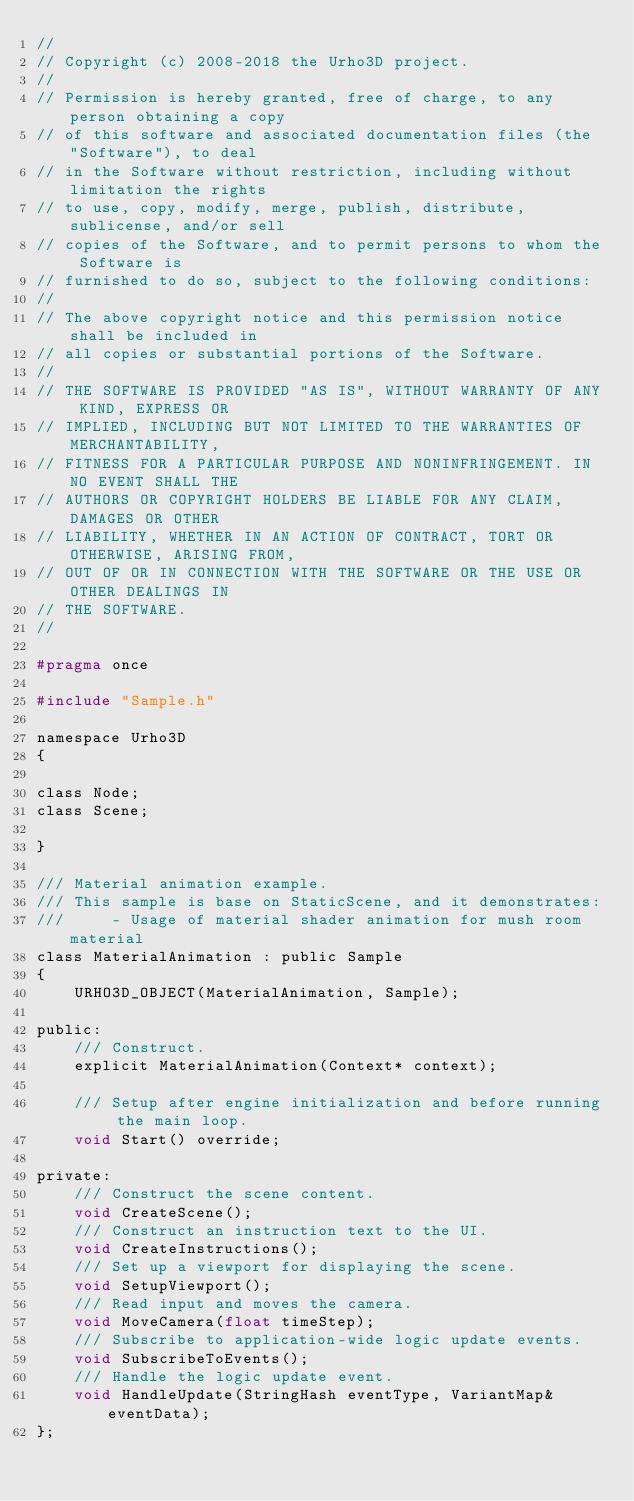Convert code to text. <code><loc_0><loc_0><loc_500><loc_500><_C_>//
// Copyright (c) 2008-2018 the Urho3D project.
//
// Permission is hereby granted, free of charge, to any person obtaining a copy
// of this software and associated documentation files (the "Software"), to deal
// in the Software without restriction, including without limitation the rights
// to use, copy, modify, merge, publish, distribute, sublicense, and/or sell
// copies of the Software, and to permit persons to whom the Software is
// furnished to do so, subject to the following conditions:
//
// The above copyright notice and this permission notice shall be included in
// all copies or substantial portions of the Software.
//
// THE SOFTWARE IS PROVIDED "AS IS", WITHOUT WARRANTY OF ANY KIND, EXPRESS OR
// IMPLIED, INCLUDING BUT NOT LIMITED TO THE WARRANTIES OF MERCHANTABILITY,
// FITNESS FOR A PARTICULAR PURPOSE AND NONINFRINGEMENT. IN NO EVENT SHALL THE
// AUTHORS OR COPYRIGHT HOLDERS BE LIABLE FOR ANY CLAIM, DAMAGES OR OTHER
// LIABILITY, WHETHER IN AN ACTION OF CONTRACT, TORT OR OTHERWISE, ARISING FROM,
// OUT OF OR IN CONNECTION WITH THE SOFTWARE OR THE USE OR OTHER DEALINGS IN
// THE SOFTWARE.
//

#pragma once

#include "Sample.h"

namespace Urho3D
{

class Node;
class Scene;

}

/// Material animation example.
/// This sample is base on StaticScene, and it demonstrates:
///     - Usage of material shader animation for mush room material
class MaterialAnimation : public Sample
{
    URHO3D_OBJECT(MaterialAnimation, Sample);

public:
    /// Construct.
    explicit MaterialAnimation(Context* context);

    /// Setup after engine initialization and before running the main loop.
    void Start() override;

private:
    /// Construct the scene content.
    void CreateScene();
    /// Construct an instruction text to the UI.
    void CreateInstructions();
    /// Set up a viewport for displaying the scene.
    void SetupViewport();
    /// Read input and moves the camera.
    void MoveCamera(float timeStep);
    /// Subscribe to application-wide logic update events.
    void SubscribeToEvents();
    /// Handle the logic update event.
    void HandleUpdate(StringHash eventType, VariantMap& eventData);
};
</code> 